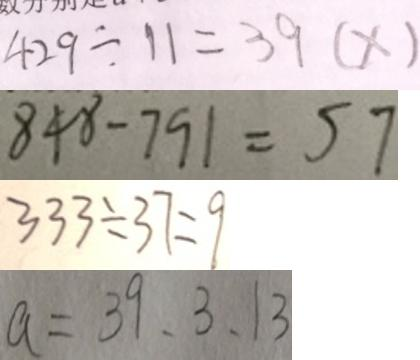Convert formula to latex. <formula><loc_0><loc_0><loc_500><loc_500>4 2 9 \div 1 1 = 3 9 ( x ) 
 8 4 8 - 7 9 1 = 5 7 
 3 3 3 \div 3 7 = 9 
 a = 3 9 、 3 、 1 3</formula> 